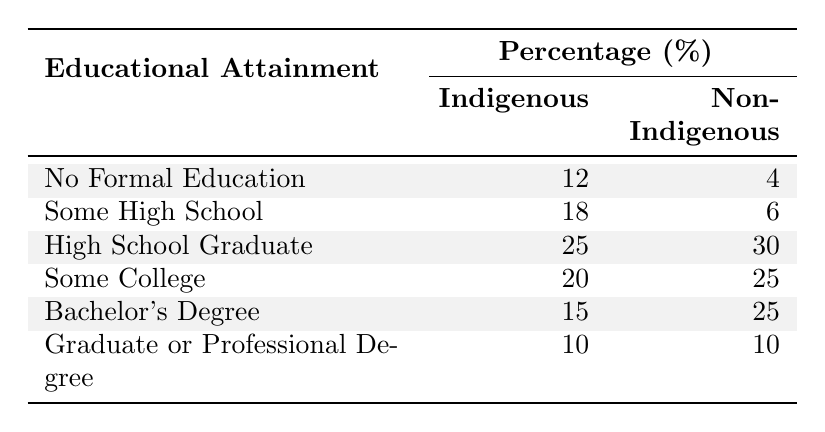What percentage of the Indigenous population has no formal education? According to the table, the percentage of the Indigenous population with no formal education is stated directly as 12%.
Answer: 12% What is the percentage of non-Indigenous individuals who are high school graduates? The table indicates that the percentage of non-Indigenous individuals who graduated high school is 30%.
Answer: 30% How many percentage points more of the Indigenous population has "Some High School" compared to the Non-Indigenous population? The percentage of Indigenous individuals with "Some High School" is 18%, while for Non-Indigenous it is 6%. The difference is 18% - 6% = 12 percentage points.
Answer: 12 What is the total percentage of Indigenous individuals with at least a high school diploma (High School Graduate, Some College, Bachelor's Degree, Graduate or Professional Degree)? Adding the percentages together: 25% (High School Graduate) + 20% (Some College) + 15% (Bachelor's Degree) + 10% (Graduate or Professional Degree) gives a total of 70% for Indigenous individuals.
Answer: 70% Is it true that the percentage of Indigenous individuals with a Bachelor's Degree is less than that of those with some college? The percentage of Indigenous individuals with a Bachelor's Degree is 15%, while those with some college is 20%. Since 15% is less than 20%, the statement is true.
Answer: Yes Which population has a higher percentage of individuals with some college education, and by how much? For Indigenous individuals, the percentage is 20%, while for Non-Indigenous it is 25%. Since 25% is greater than 20%, Non-Indigenous has a higher percentage by 5 percentage points (25% - 20%).
Answer: Non-Indigenous, 5 percentage points What percentage of Indigenous and Non-Indigenous populations have the same educational attainment level? The only level where the percentages are the same is for the "Graduate or Professional Degree", where both populations have 10%.
Answer: 10% Calculate the average percentage of educational attainment for the Indigenous population. To find the average, sum the percentages: (12 + 18 + 25 + 20 + 15 + 10) = 100. There are 6 levels, so the average is 100/6 ≈ 16.67%.
Answer: 16.67% How many percentage points difference exist between the highest and lowest educational attainment levels for Indigenous individuals? The highest percentage for Indigenous individuals is 25% (High School Graduate) and the lowest is 10% (Graduate or Professional Degree). The difference is 25% - 10% = 15 percentage points.
Answer: 15 What is the predominant level of educational attainment among Indigenous individuals? The highest percentage for Indigenous individuals is 25% for High School Graduates, which indicates that this is the predominant level of educational attainment among them.
Answer: High School Graduate Which educational attainment level has the lowest representation for both populations? Looking at the table, "No Formal Education" has the lowest representation for the Indigenous population at 12% and the Non-Indigenous population at 4%, being the lowest for both.
Answer: No Formal Education 